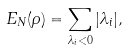<formula> <loc_0><loc_0><loc_500><loc_500>E _ { N } ( \rho ) = \sum _ { \lambda _ { i } < 0 } | \lambda _ { i } | ,</formula> 